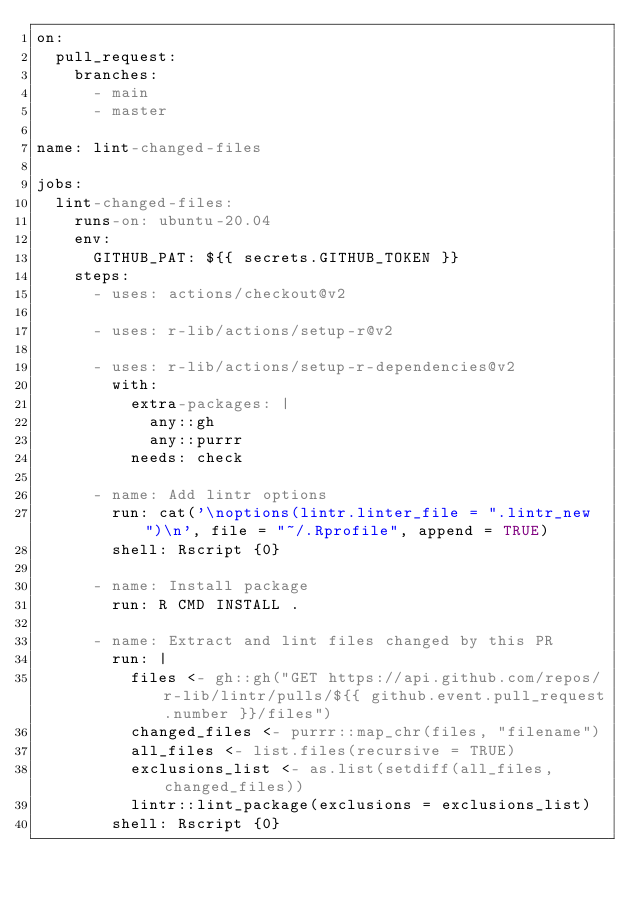Convert code to text. <code><loc_0><loc_0><loc_500><loc_500><_YAML_>on:
  pull_request:
    branches:
      - main
      - master

name: lint-changed-files

jobs:
  lint-changed-files:
    runs-on: ubuntu-20.04
    env:
      GITHUB_PAT: ${{ secrets.GITHUB_TOKEN }}
    steps:
      - uses: actions/checkout@v2

      - uses: r-lib/actions/setup-r@v2

      - uses: r-lib/actions/setup-r-dependencies@v2
        with:
          extra-packages: |
            any::gh
            any::purrr
          needs: check

      - name: Add lintr options
        run: cat('\noptions(lintr.linter_file = ".lintr_new")\n', file = "~/.Rprofile", append = TRUE)
        shell: Rscript {0}

      - name: Install package
        run: R CMD INSTALL .

      - name: Extract and lint files changed by this PR
        run: |
          files <- gh::gh("GET https://api.github.com/repos/r-lib/lintr/pulls/${{ github.event.pull_request.number }}/files")
          changed_files <- purrr::map_chr(files, "filename")
          all_files <- list.files(recursive = TRUE)
          exclusions_list <- as.list(setdiff(all_files, changed_files))
          lintr::lint_package(exclusions = exclusions_list)
        shell: Rscript {0}
</code> 